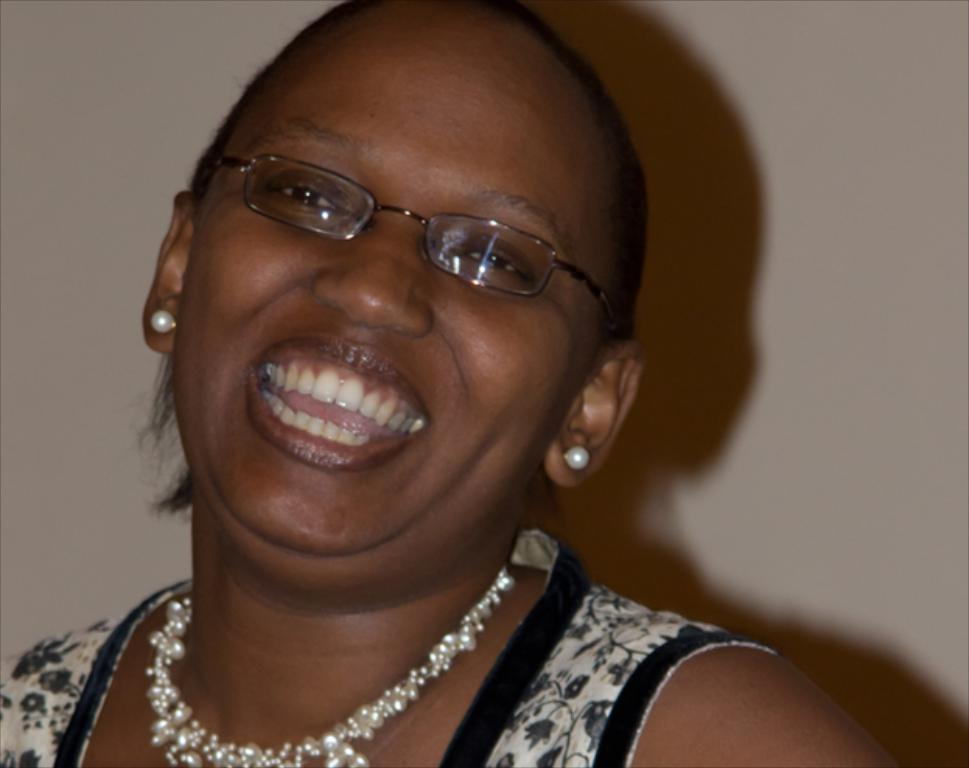Who is present in the image? There is a woman in the image. What is the woman doing in the image? The woman is smiling in the image. What accessory is the woman wearing in the image? The woman is wearing glasses in the image. What can be seen in the background of the image? There is a wall in the background of the image. What type of baseball shoe is the woman wearing in the image? There is no baseball shoe or any reference to baseball in the image; the woman is wearing glasses. Can you describe the woman's toe in the image? There is no specific focus on the woman's toe in the image, so it cannot be described in detail. 